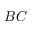Convert formula to latex. <formula><loc_0><loc_0><loc_500><loc_500>B C</formula> 